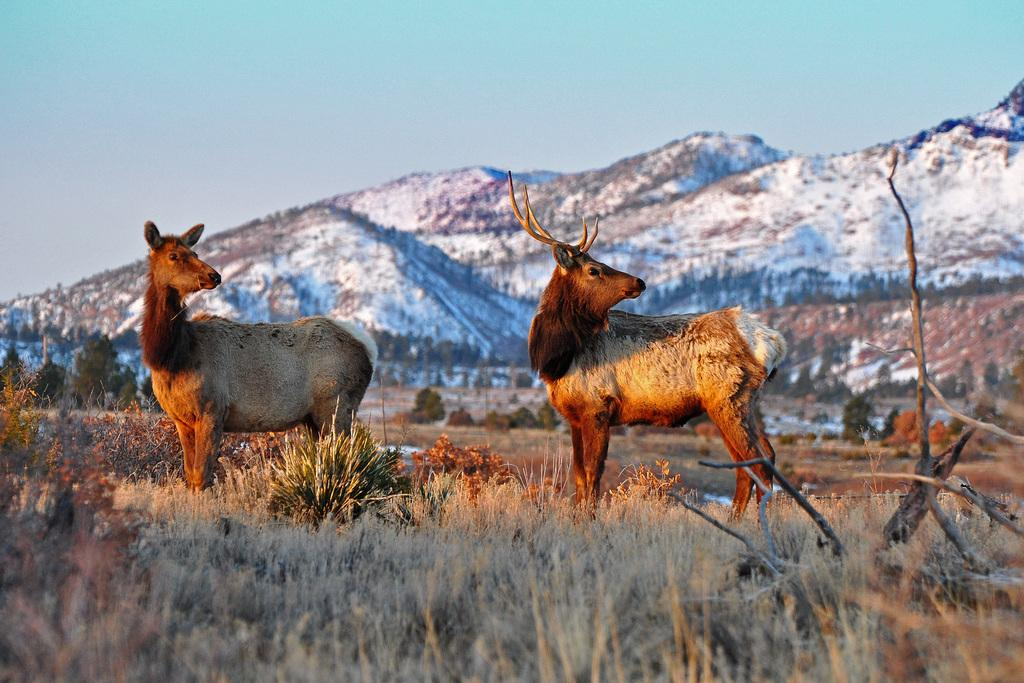How many animals are present in the image? There are two animals in the image. Where are the animals located? The animals are on the grass. What can be seen in the background of the image? There are mountains visible in the background of the image. What part of the natural environment is visible in the image? The sky is visible in the image. Who is telling a joke in the image? There is no person present in the image, and therefore no one is telling a joke. What type of rail can be seen in the image? There is no rail present in the image. 